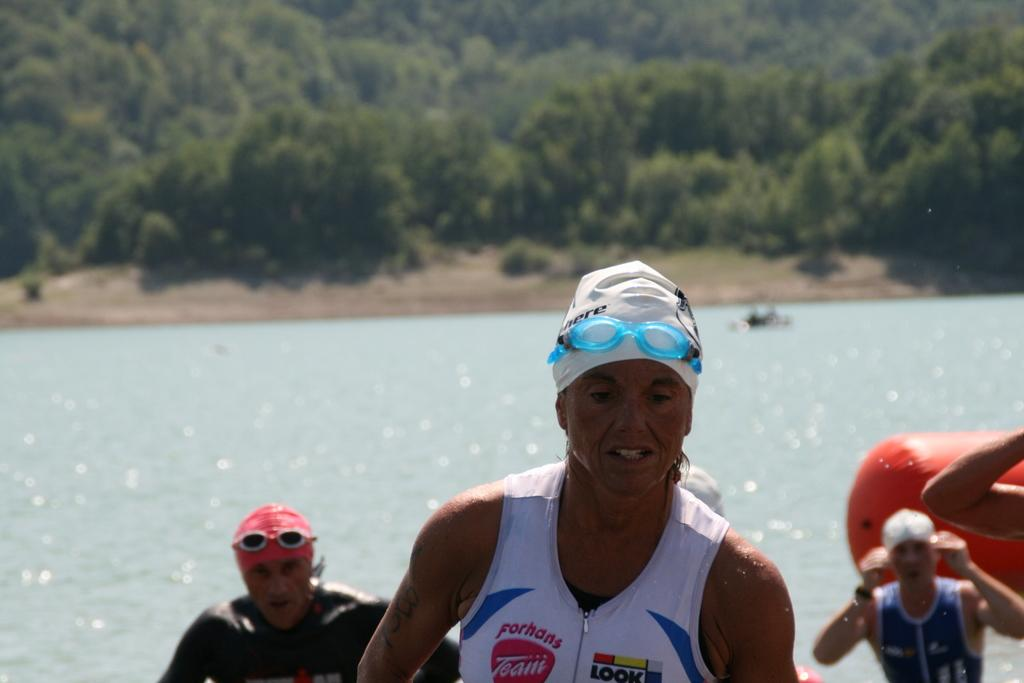Who or what is present in the image? There are people in the image. What are the people wearing? The people are wearing goggles. What can be seen in the background of the image? There is water and trees visible in the image. What type of rhythm can be heard coming from the trees in the image? There is no sound or rhythm present in the image; it only shows people wearing goggles and the background elements of water and trees. 